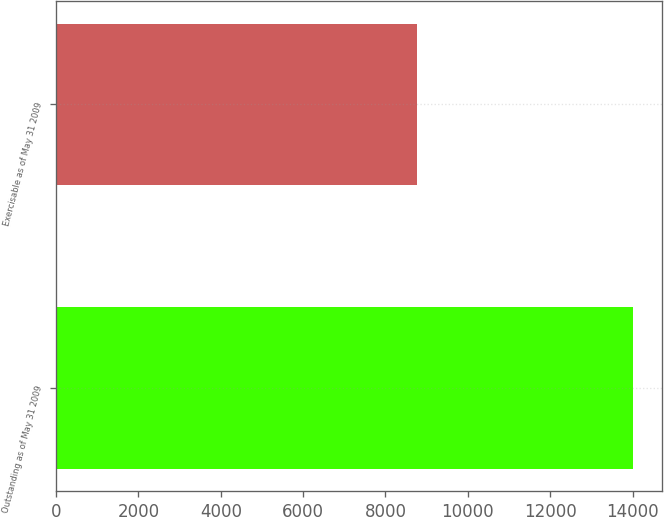Convert chart to OTSL. <chart><loc_0><loc_0><loc_500><loc_500><bar_chart><fcel>Outstanding as of May 31 2009<fcel>Exercisable as of May 31 2009<nl><fcel>14003<fcel>8763<nl></chart> 